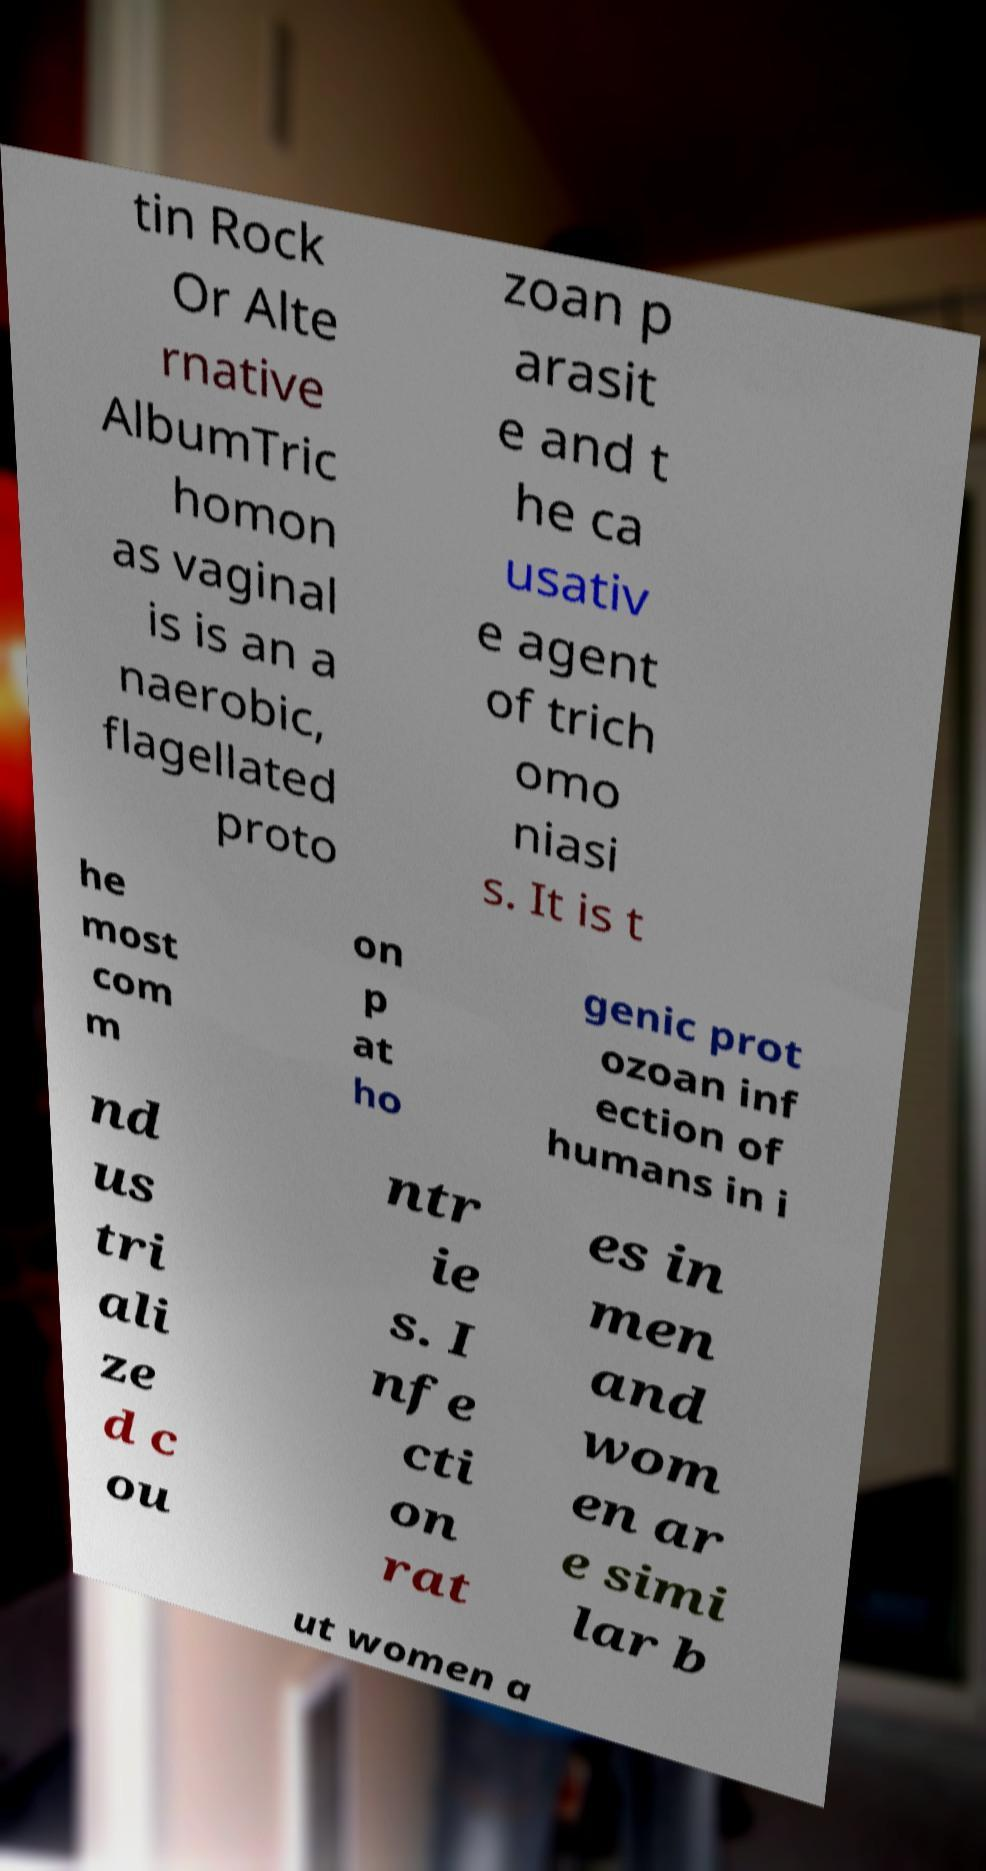What messages or text are displayed in this image? I need them in a readable, typed format. tin Rock Or Alte rnative AlbumTric homon as vaginal is is an a naerobic, flagellated proto zoan p arasit e and t he ca usativ e agent of trich omo niasi s. It is t he most com m on p at ho genic prot ozoan inf ection of humans in i nd us tri ali ze d c ou ntr ie s. I nfe cti on rat es in men and wom en ar e simi lar b ut women a 